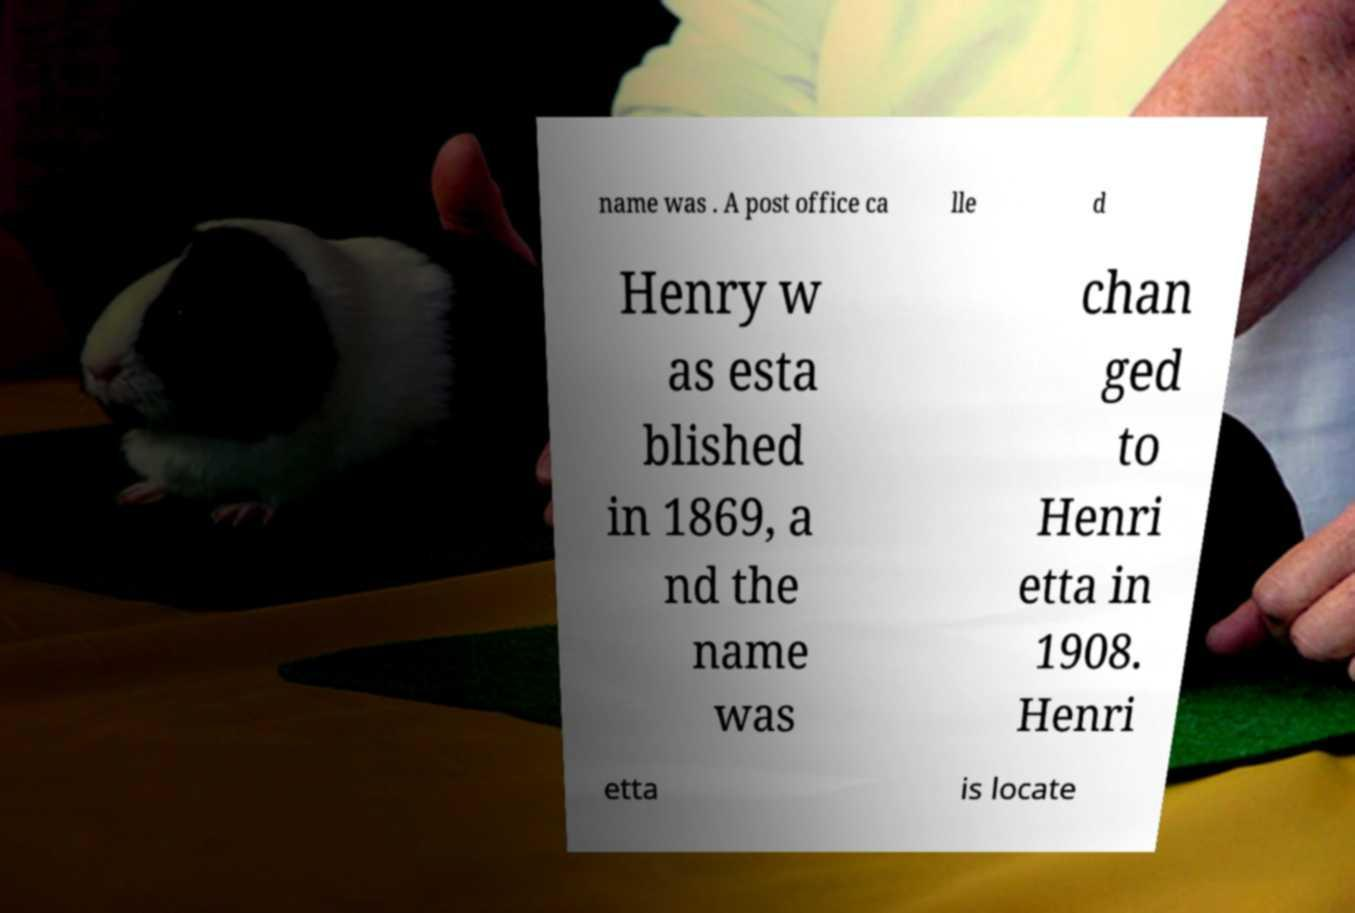For documentation purposes, I need the text within this image transcribed. Could you provide that? name was . A post office ca lle d Henry w as esta blished in 1869, a nd the name was chan ged to Henri etta in 1908. Henri etta is locate 